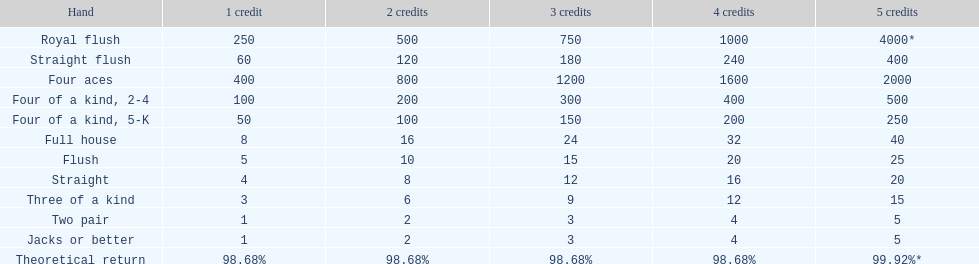What number is a multiple for every four aces victory? 400. Could you help me parse every detail presented in this table? {'header': ['Hand', '1 credit', '2 credits', '3 credits', '4 credits', '5 credits'], 'rows': [['Royal flush', '250', '500', '750', '1000', '4000*'], ['Straight flush', '60', '120', '180', '240', '400'], ['Four aces', '400', '800', '1200', '1600', '2000'], ['Four of a kind, 2-4', '100', '200', '300', '400', '500'], ['Four of a kind, 5-K', '50', '100', '150', '200', '250'], ['Full house', '8', '16', '24', '32', '40'], ['Flush', '5', '10', '15', '20', '25'], ['Straight', '4', '8', '12', '16', '20'], ['Three of a kind', '3', '6', '9', '12', '15'], ['Two pair', '1', '2', '3', '4', '5'], ['Jacks or better', '1', '2', '3', '4', '5'], ['Theoretical return', '98.68%', '98.68%', '98.68%', '98.68%', '99.92%*']]} 